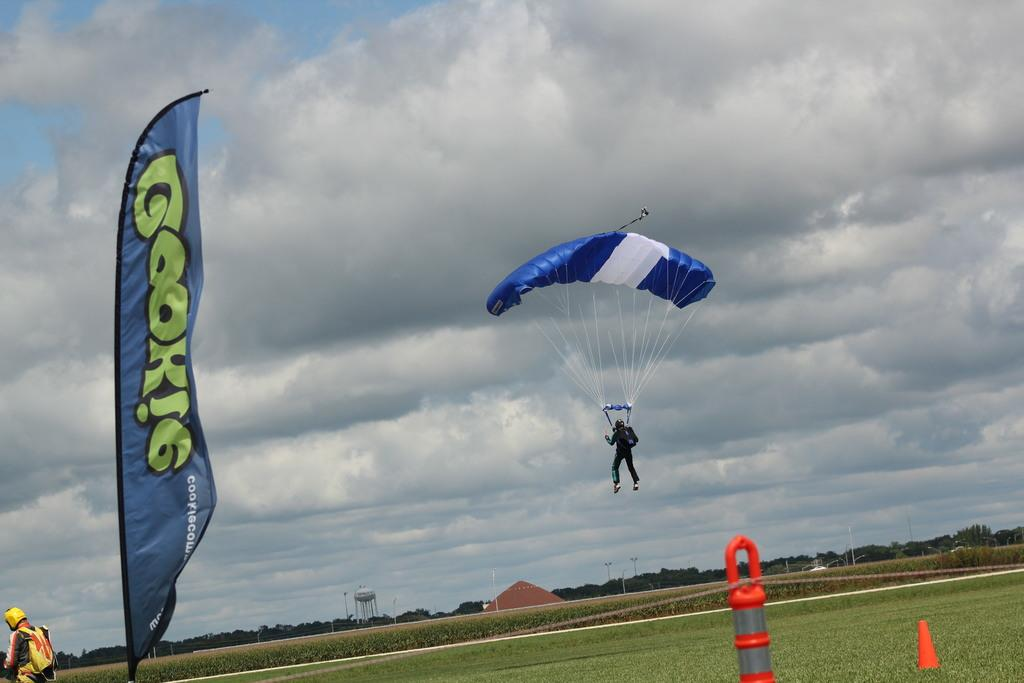What is hanging in the image? There is a banner in the image. How many people are in the image? There are two people in the image. What is being used for descent in the image? There is a parachute in the image. What type of structure is present in the image? There is a water pipe in the image. What type of vegetation is visible in the image? There is grass in the image. What can be seen in the background of the image? There are trees in the background of the image. What is visible at the top of the image? The sky is visible at the top of the image. What can be seen in the sky? A: Clouds are present in the sky. How many bees are buzzing around the water pipe in the image? There are no bees present in the image. What type of crime is the crook committing in the image? There is no crook or crime depicted in the image. 